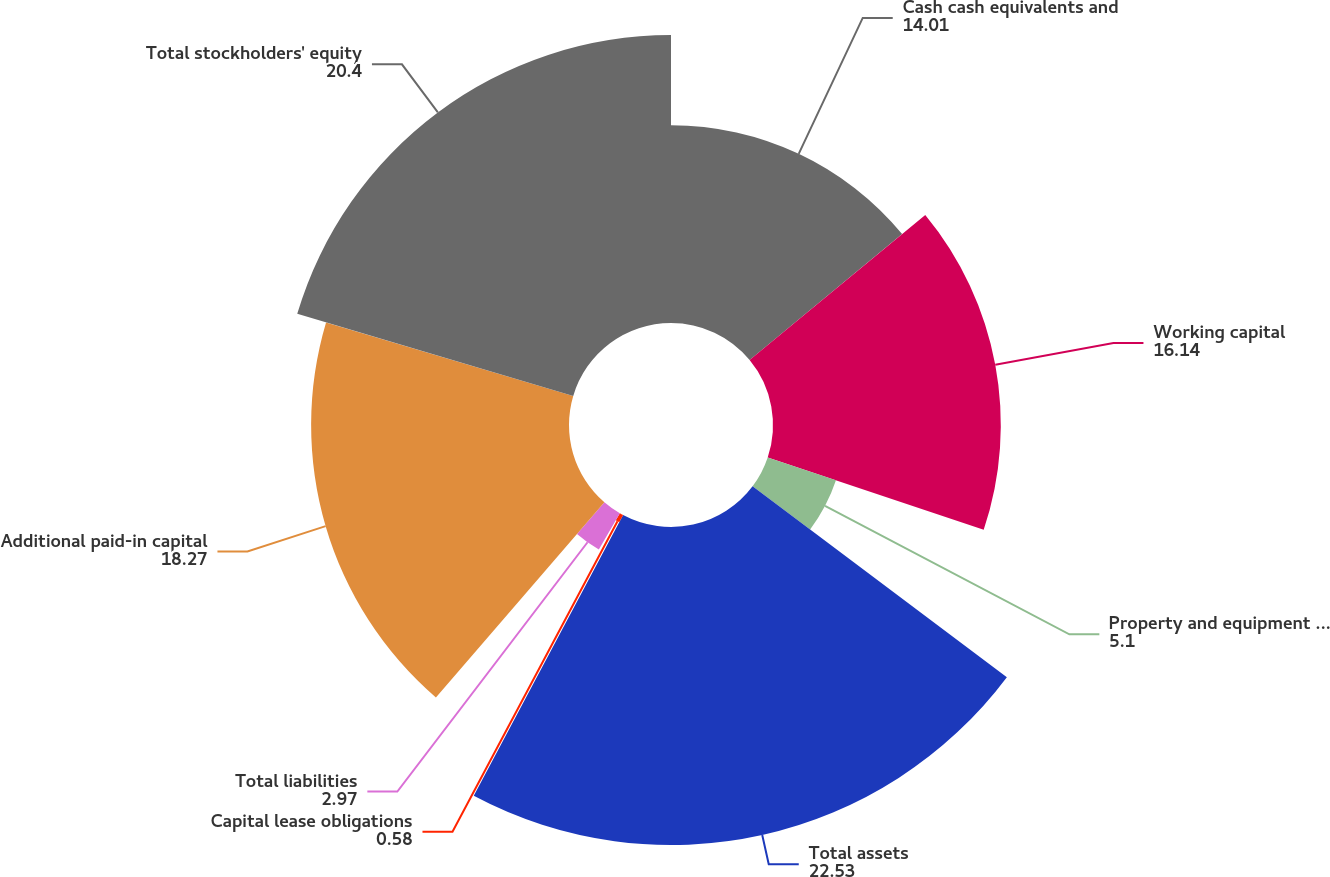Convert chart to OTSL. <chart><loc_0><loc_0><loc_500><loc_500><pie_chart><fcel>Cash cash equivalents and<fcel>Working capital<fcel>Property and equipment net<fcel>Total assets<fcel>Capital lease obligations<fcel>Total liabilities<fcel>Additional paid-in capital<fcel>Total stockholders' equity<nl><fcel>14.01%<fcel>16.14%<fcel>5.1%<fcel>22.53%<fcel>0.58%<fcel>2.97%<fcel>18.27%<fcel>20.4%<nl></chart> 